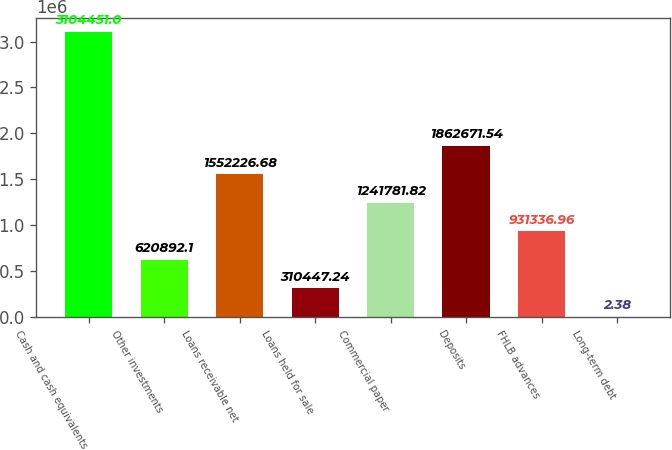Convert chart to OTSL. <chart><loc_0><loc_0><loc_500><loc_500><bar_chart><fcel>Cash and cash equivalents<fcel>Other investments<fcel>Loans receivable net<fcel>Loans held for sale<fcel>Commercial paper<fcel>Deposits<fcel>FHLB advances<fcel>Long-term debt<nl><fcel>3.10445e+06<fcel>620892<fcel>1.55223e+06<fcel>310447<fcel>1.24178e+06<fcel>1.86267e+06<fcel>931337<fcel>2.38<nl></chart> 